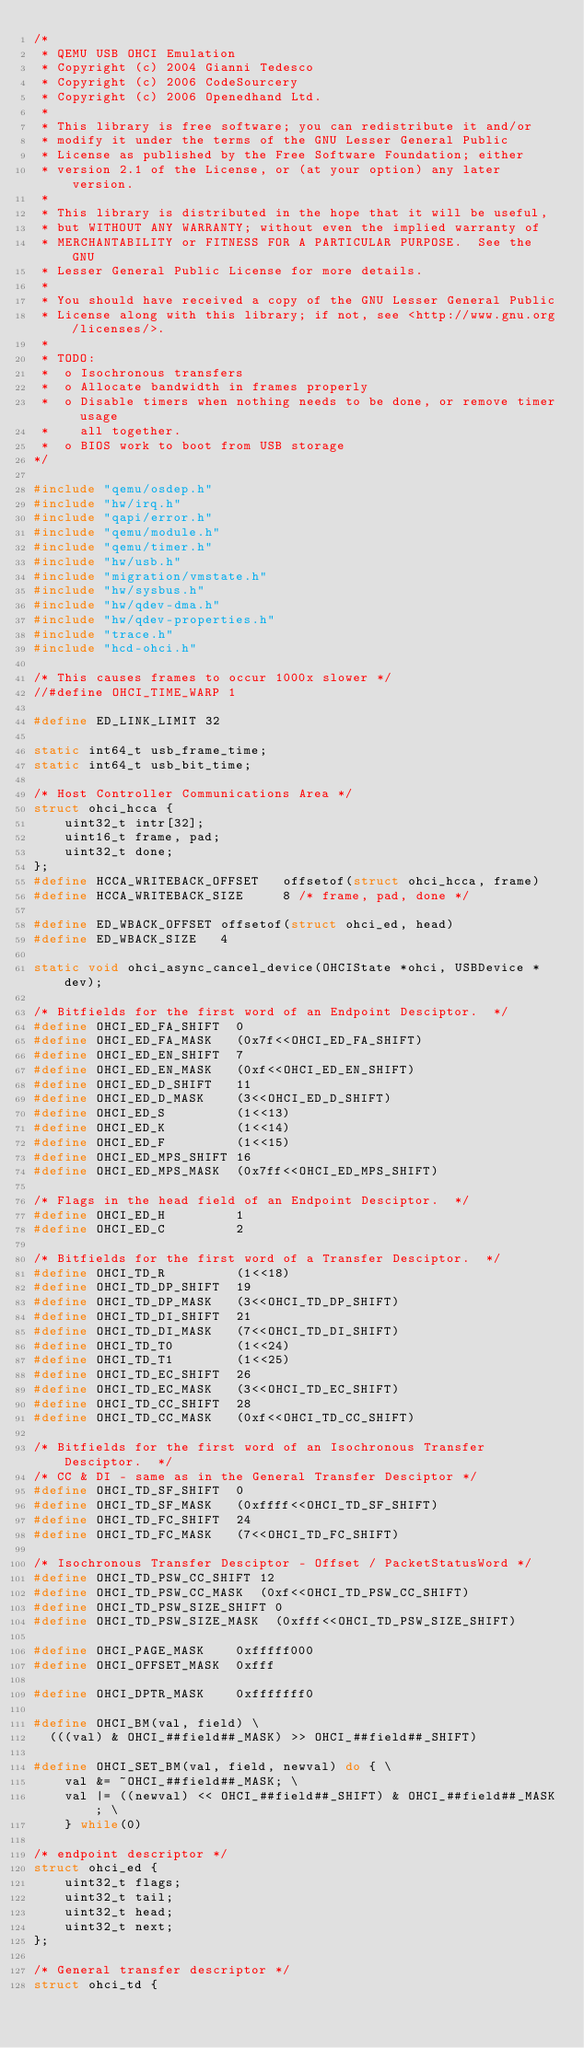<code> <loc_0><loc_0><loc_500><loc_500><_C_>/*
 * QEMU USB OHCI Emulation
 * Copyright (c) 2004 Gianni Tedesco
 * Copyright (c) 2006 CodeSourcery
 * Copyright (c) 2006 Openedhand Ltd.
 *
 * This library is free software; you can redistribute it and/or
 * modify it under the terms of the GNU Lesser General Public
 * License as published by the Free Software Foundation; either
 * version 2.1 of the License, or (at your option) any later version.
 *
 * This library is distributed in the hope that it will be useful,
 * but WITHOUT ANY WARRANTY; without even the implied warranty of
 * MERCHANTABILITY or FITNESS FOR A PARTICULAR PURPOSE.  See the GNU
 * Lesser General Public License for more details.
 *
 * You should have received a copy of the GNU Lesser General Public
 * License along with this library; if not, see <http://www.gnu.org/licenses/>.
 *
 * TODO:
 *  o Isochronous transfers
 *  o Allocate bandwidth in frames properly
 *  o Disable timers when nothing needs to be done, or remove timer usage
 *    all together.
 *  o BIOS work to boot from USB storage
*/

#include "qemu/osdep.h"
#include "hw/irq.h"
#include "qapi/error.h"
#include "qemu/module.h"
#include "qemu/timer.h"
#include "hw/usb.h"
#include "migration/vmstate.h"
#include "hw/sysbus.h"
#include "hw/qdev-dma.h"
#include "hw/qdev-properties.h"
#include "trace.h"
#include "hcd-ohci.h"

/* This causes frames to occur 1000x slower */
//#define OHCI_TIME_WARP 1

#define ED_LINK_LIMIT 32

static int64_t usb_frame_time;
static int64_t usb_bit_time;

/* Host Controller Communications Area */
struct ohci_hcca {
    uint32_t intr[32];
    uint16_t frame, pad;
    uint32_t done;
};
#define HCCA_WRITEBACK_OFFSET   offsetof(struct ohci_hcca, frame)
#define HCCA_WRITEBACK_SIZE     8 /* frame, pad, done */

#define ED_WBACK_OFFSET offsetof(struct ohci_ed, head)
#define ED_WBACK_SIZE   4

static void ohci_async_cancel_device(OHCIState *ohci, USBDevice *dev);

/* Bitfields for the first word of an Endpoint Desciptor.  */
#define OHCI_ED_FA_SHIFT  0
#define OHCI_ED_FA_MASK   (0x7f<<OHCI_ED_FA_SHIFT)
#define OHCI_ED_EN_SHIFT  7
#define OHCI_ED_EN_MASK   (0xf<<OHCI_ED_EN_SHIFT)
#define OHCI_ED_D_SHIFT   11
#define OHCI_ED_D_MASK    (3<<OHCI_ED_D_SHIFT)
#define OHCI_ED_S         (1<<13)
#define OHCI_ED_K         (1<<14)
#define OHCI_ED_F         (1<<15)
#define OHCI_ED_MPS_SHIFT 16
#define OHCI_ED_MPS_MASK  (0x7ff<<OHCI_ED_MPS_SHIFT)

/* Flags in the head field of an Endpoint Desciptor.  */
#define OHCI_ED_H         1
#define OHCI_ED_C         2

/* Bitfields for the first word of a Transfer Desciptor.  */
#define OHCI_TD_R         (1<<18)
#define OHCI_TD_DP_SHIFT  19
#define OHCI_TD_DP_MASK   (3<<OHCI_TD_DP_SHIFT)
#define OHCI_TD_DI_SHIFT  21
#define OHCI_TD_DI_MASK   (7<<OHCI_TD_DI_SHIFT)
#define OHCI_TD_T0        (1<<24)
#define OHCI_TD_T1        (1<<25)
#define OHCI_TD_EC_SHIFT  26
#define OHCI_TD_EC_MASK   (3<<OHCI_TD_EC_SHIFT)
#define OHCI_TD_CC_SHIFT  28
#define OHCI_TD_CC_MASK   (0xf<<OHCI_TD_CC_SHIFT)

/* Bitfields for the first word of an Isochronous Transfer Desciptor.  */
/* CC & DI - same as in the General Transfer Desciptor */
#define OHCI_TD_SF_SHIFT  0
#define OHCI_TD_SF_MASK   (0xffff<<OHCI_TD_SF_SHIFT)
#define OHCI_TD_FC_SHIFT  24
#define OHCI_TD_FC_MASK   (7<<OHCI_TD_FC_SHIFT)

/* Isochronous Transfer Desciptor - Offset / PacketStatusWord */
#define OHCI_TD_PSW_CC_SHIFT 12
#define OHCI_TD_PSW_CC_MASK  (0xf<<OHCI_TD_PSW_CC_SHIFT)
#define OHCI_TD_PSW_SIZE_SHIFT 0
#define OHCI_TD_PSW_SIZE_MASK  (0xfff<<OHCI_TD_PSW_SIZE_SHIFT)

#define OHCI_PAGE_MASK    0xfffff000
#define OHCI_OFFSET_MASK  0xfff

#define OHCI_DPTR_MASK    0xfffffff0

#define OHCI_BM(val, field) \
  (((val) & OHCI_##field##_MASK) >> OHCI_##field##_SHIFT)

#define OHCI_SET_BM(val, field, newval) do { \
    val &= ~OHCI_##field##_MASK; \
    val |= ((newval) << OHCI_##field##_SHIFT) & OHCI_##field##_MASK; \
    } while(0)

/* endpoint descriptor */
struct ohci_ed {
    uint32_t flags;
    uint32_t tail;
    uint32_t head;
    uint32_t next;
};

/* General transfer descriptor */
struct ohci_td {</code> 